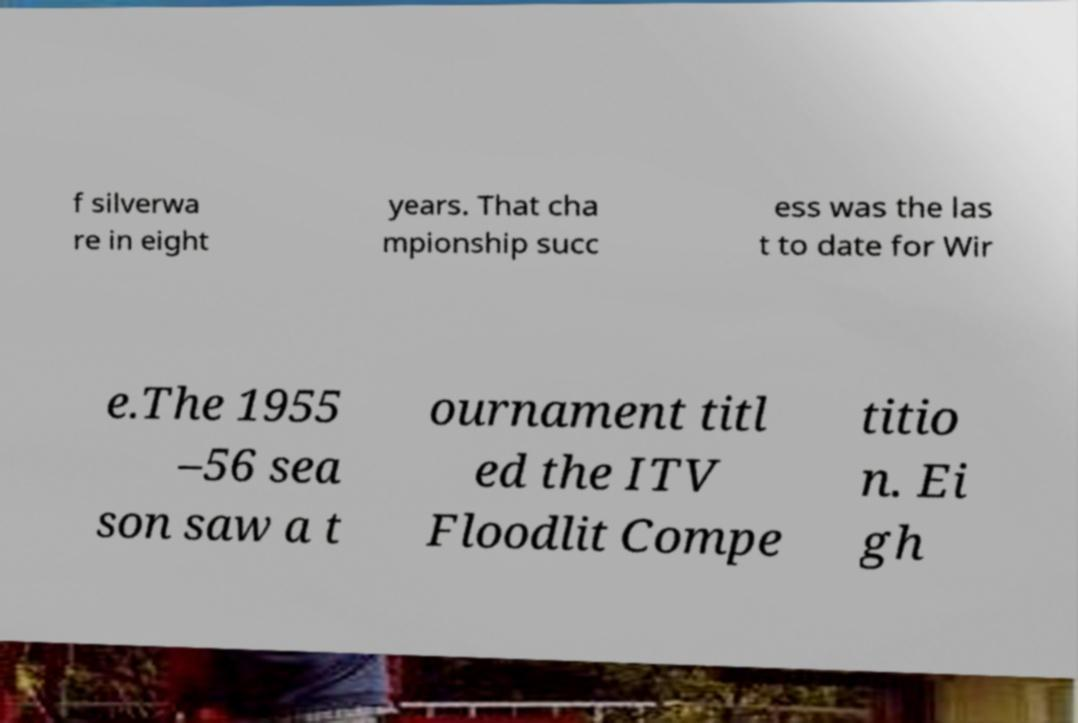For documentation purposes, I need the text within this image transcribed. Could you provide that? f silverwa re in eight years. That cha mpionship succ ess was the las t to date for Wir e.The 1955 –56 sea son saw a t ournament titl ed the ITV Floodlit Compe titio n. Ei gh 